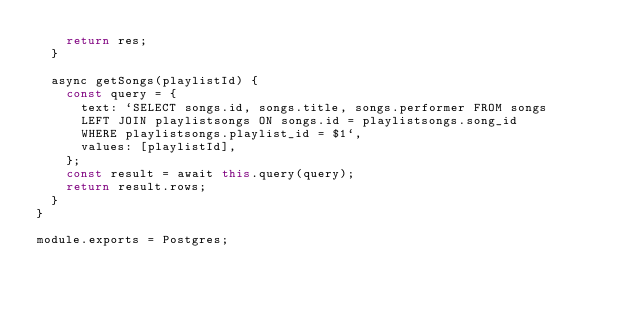Convert code to text. <code><loc_0><loc_0><loc_500><loc_500><_JavaScript_>    return res;
  }

  async getSongs(playlistId) {
    const query = {
      text: `SELECT songs.id, songs.title, songs.performer FROM songs
      LEFT JOIN playlistsongs ON songs.id = playlistsongs.song_id
      WHERE playlistsongs.playlist_id = $1`,
      values: [playlistId],
    };
    const result = await this.query(query);
    return result.rows;
  }
}

module.exports = Postgres;
</code> 